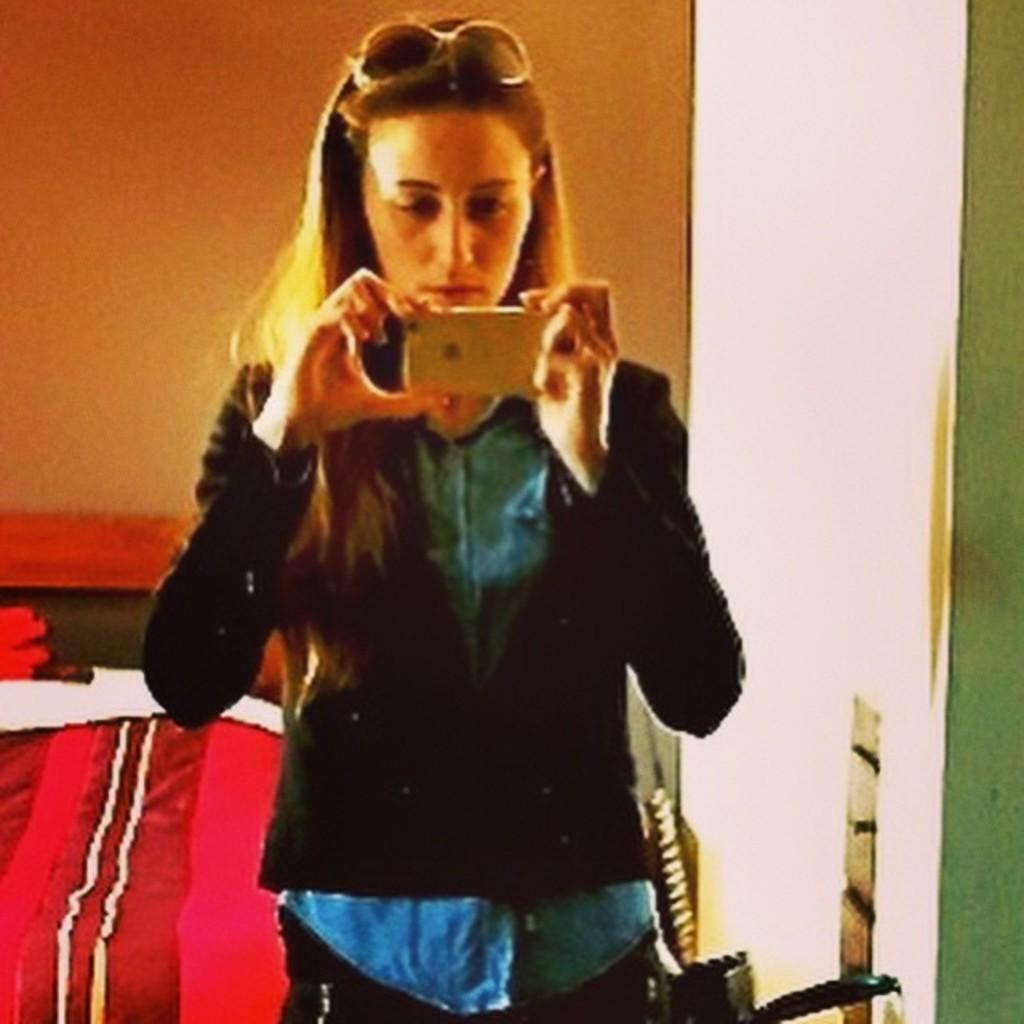What is the main subject of the image? The main subject of the image is a woman. What is the woman doing in the image? The woman is standing and taking a picture. What type of straw is the woman using to collect coal in the image? There is no straw or coal present in the image; the woman is taking a picture. 